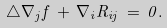Convert formula to latex. <formula><loc_0><loc_0><loc_500><loc_500>\triangle \nabla _ { j } f \, + \, \nabla _ { i } R _ { i j } \, = \, 0 .</formula> 